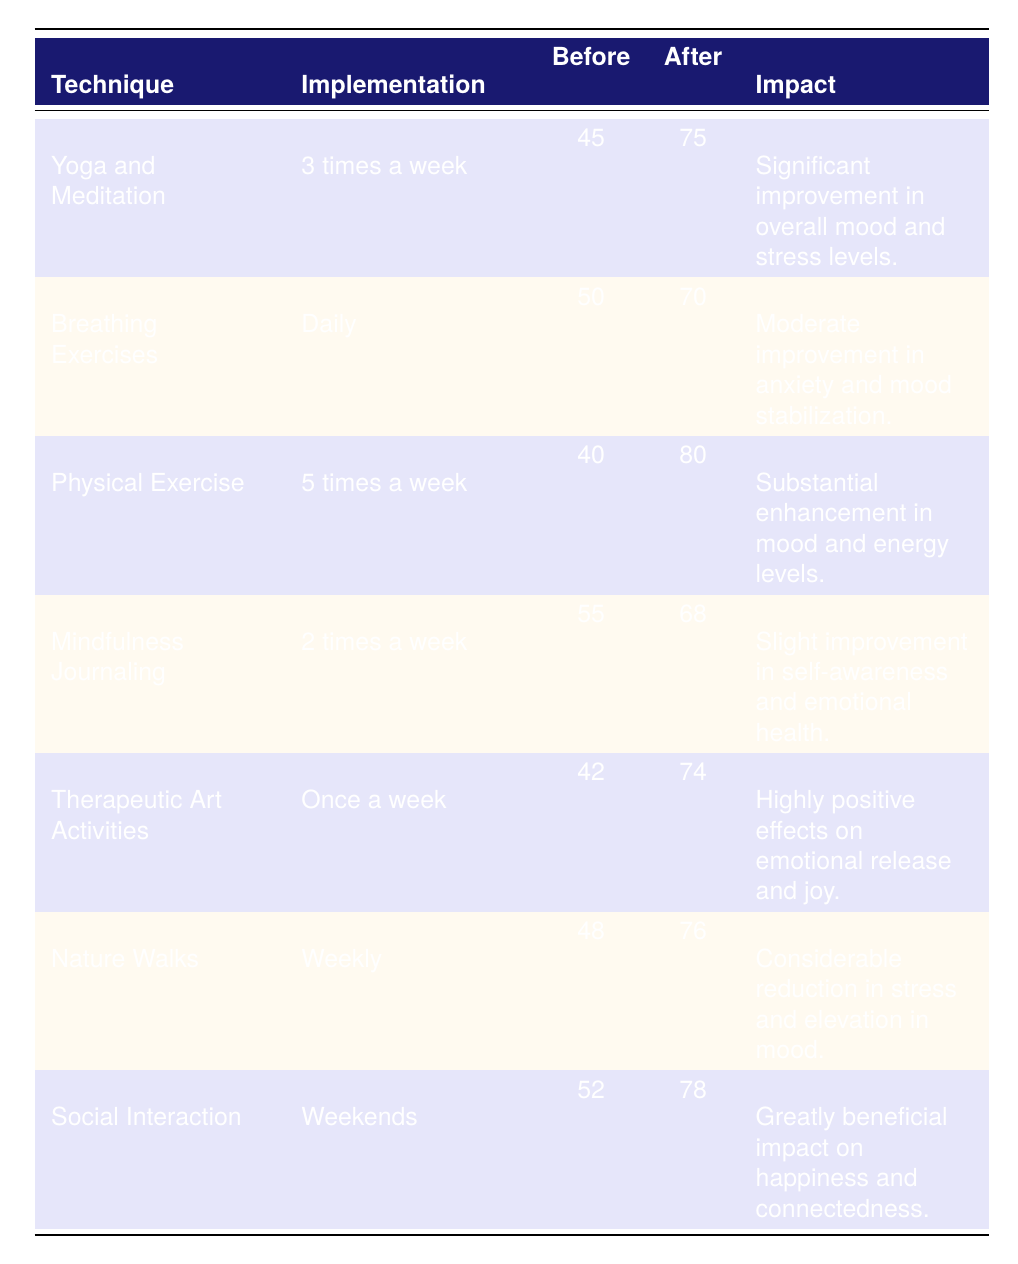What's the implementation frequency for Yoga and Meditation? The table lists the implementation frequency for Yoga and Meditation in the second column, which is "3 times a week."
Answer: 3 times a week What was the average mood score before implementing Breathing Exercises? The average mood score before implementing Breathing Exercises is found in the third column, which shows "50."
Answer: 50 Which technique had the highest average mood score after implementation? By comparing the values in the fourth column for each technique, Physical Exercise has the highest average mood score after at "80."
Answer: Physical Exercise What is the total improvement in mood score for Therapeutic Art Activities? The improvement is calculated by subtracting the average mood score before (42) from the average after (74). Thus, 74 - 42 = 32.
Answer: 32 Did Social Interaction result in a higher mood score after implementation than before? Looking at the respective scores for Social Interaction, the average before is 52 and after is 78, indicating a clear increase. Yes, it did result in a higher score.
Answer: Yes What is the average mood score increase across all techniques listed? To find the average increase, calculate the difference for each technique (After - Before): Yoga (30), Breathing (20), Physical Exercise (40), Mindfulness (13), Art (32), Nature (28), Social (26). Sum of increases = 30 + 20 + 40 + 13 + 32 + 28 + 26 = 189. There are 7 techniques, so the average increase is 189/7 = 27.
Answer: 27 Which technique showed a slight improvement in mood scores? The impact descriptions in the last column indicate that Mindfulness Journaling resulted in "Slight improvement in self-awareness and emotional health."
Answer: Mindfulness Journaling Which two techniques had the same impact descriptor related to mood changes? Checking the impact column reveals that Breathing Exercises and Mindfulness Journaling both describe their improvements as "Moderate improvement in anxiety and mood stabilization."
Answer: Breathing Exercises and Mindfulness Journaling What is the median average mood score before the implementation of any techniques? Listing the average mood scores before implementation: 45, 50, 40, 55, 42, 48, 52; arranged: 40, 42, 45, 48, 50, 52, 55. The median is the middle value, which is 48.
Answer: 48 Which stress management technique had the smallest improvement in mood score? The differences in mood scores indicate that Mindfulness Journaling had the smallest improvement, with an increase of 13 points (68 - 55).
Answer: Mindfulness Journaling 